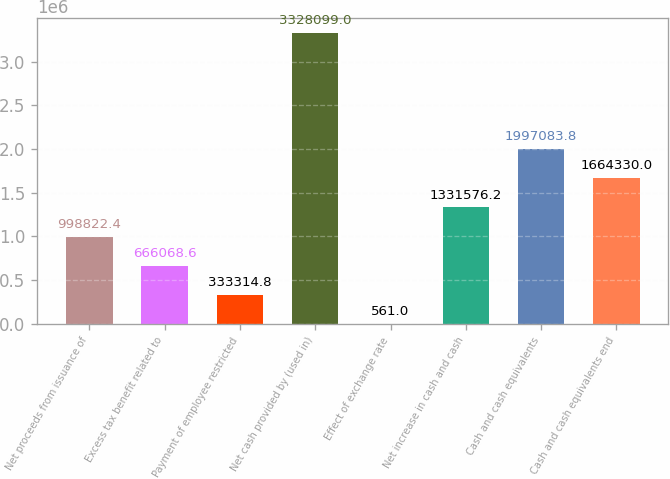Convert chart to OTSL. <chart><loc_0><loc_0><loc_500><loc_500><bar_chart><fcel>Net proceeds from issuance of<fcel>Excess tax benefit related to<fcel>Payment of employee restricted<fcel>Net cash provided by (used in)<fcel>Effect of exchange rate<fcel>Net increase in cash and cash<fcel>Cash and cash equivalents<fcel>Cash and cash equivalents end<nl><fcel>998822<fcel>666069<fcel>333315<fcel>3.3281e+06<fcel>561<fcel>1.33158e+06<fcel>1.99708e+06<fcel>1.66433e+06<nl></chart> 